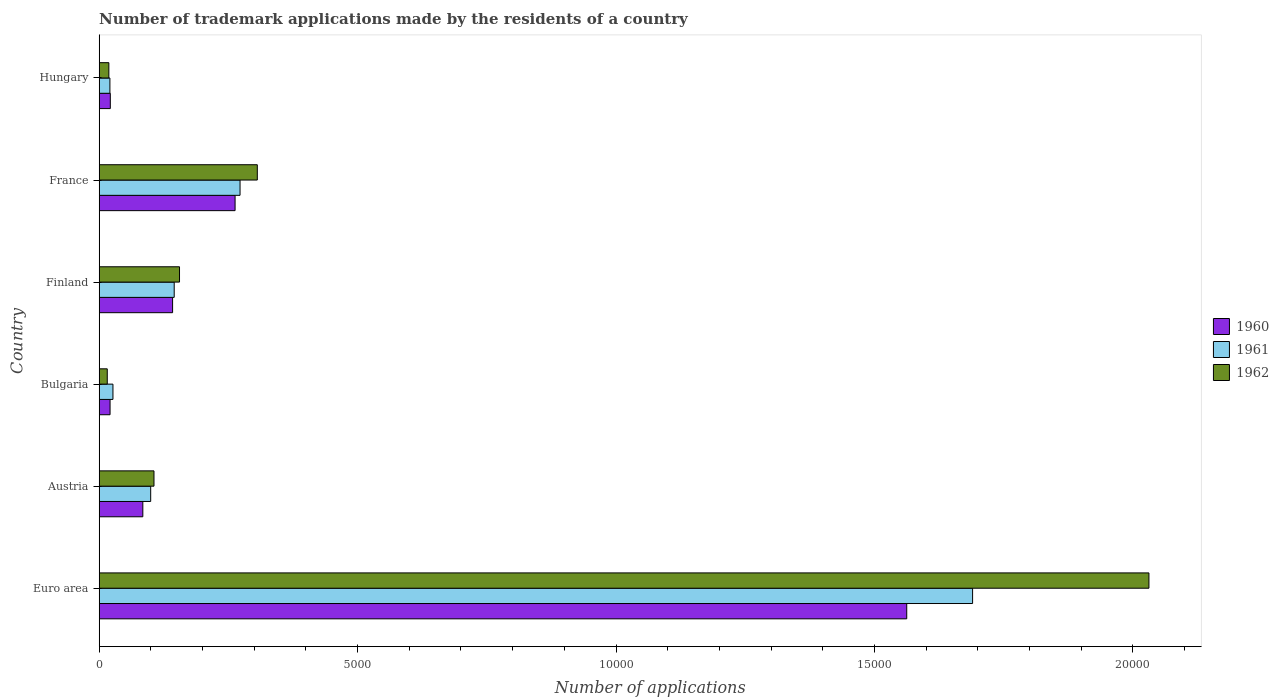What is the label of the 6th group of bars from the top?
Your answer should be compact. Euro area. What is the number of trademark applications made by the residents in 1962 in Austria?
Provide a short and direct response. 1061. Across all countries, what is the maximum number of trademark applications made by the residents in 1962?
Your response must be concise. 2.03e+04. Across all countries, what is the minimum number of trademark applications made by the residents in 1961?
Your response must be concise. 208. In which country was the number of trademark applications made by the residents in 1961 maximum?
Your answer should be very brief. Euro area. What is the total number of trademark applications made by the residents in 1961 in the graph?
Offer a very short reply. 2.25e+04. What is the difference between the number of trademark applications made by the residents in 1962 in Euro area and that in France?
Keep it short and to the point. 1.73e+04. What is the difference between the number of trademark applications made by the residents in 1960 in Bulgaria and the number of trademark applications made by the residents in 1961 in France?
Keep it short and to the point. -2515. What is the average number of trademark applications made by the residents in 1962 per country?
Offer a very short reply. 4388.67. In how many countries, is the number of trademark applications made by the residents in 1962 greater than 14000 ?
Ensure brevity in your answer.  1. What is the ratio of the number of trademark applications made by the residents in 1962 in Finland to that in Hungary?
Offer a terse response. 8.27. What is the difference between the highest and the second highest number of trademark applications made by the residents in 1962?
Your answer should be compact. 1.73e+04. What is the difference between the highest and the lowest number of trademark applications made by the residents in 1960?
Provide a short and direct response. 1.54e+04. In how many countries, is the number of trademark applications made by the residents in 1960 greater than the average number of trademark applications made by the residents in 1960 taken over all countries?
Your answer should be very brief. 1. Is the sum of the number of trademark applications made by the residents in 1961 in Euro area and Finland greater than the maximum number of trademark applications made by the residents in 1962 across all countries?
Provide a succinct answer. No. What does the 1st bar from the bottom in Hungary represents?
Your response must be concise. 1960. Is it the case that in every country, the sum of the number of trademark applications made by the residents in 1960 and number of trademark applications made by the residents in 1961 is greater than the number of trademark applications made by the residents in 1962?
Offer a terse response. Yes. Are all the bars in the graph horizontal?
Make the answer very short. Yes. Are the values on the major ticks of X-axis written in scientific E-notation?
Make the answer very short. No. Does the graph contain any zero values?
Your answer should be compact. No. Does the graph contain grids?
Offer a terse response. No. How many legend labels are there?
Your answer should be very brief. 3. What is the title of the graph?
Your response must be concise. Number of trademark applications made by the residents of a country. What is the label or title of the X-axis?
Give a very brief answer. Number of applications. What is the label or title of the Y-axis?
Give a very brief answer. Country. What is the Number of applications of 1960 in Euro area?
Provide a short and direct response. 1.56e+04. What is the Number of applications in 1961 in Euro area?
Offer a terse response. 1.69e+04. What is the Number of applications of 1962 in Euro area?
Make the answer very short. 2.03e+04. What is the Number of applications of 1960 in Austria?
Your answer should be compact. 845. What is the Number of applications in 1961 in Austria?
Offer a very short reply. 997. What is the Number of applications in 1962 in Austria?
Provide a short and direct response. 1061. What is the Number of applications in 1960 in Bulgaria?
Provide a short and direct response. 211. What is the Number of applications in 1961 in Bulgaria?
Keep it short and to the point. 267. What is the Number of applications of 1962 in Bulgaria?
Your answer should be very brief. 157. What is the Number of applications of 1960 in Finland?
Provide a succinct answer. 1421. What is the Number of applications of 1961 in Finland?
Your answer should be very brief. 1452. What is the Number of applications of 1962 in Finland?
Make the answer very short. 1555. What is the Number of applications in 1960 in France?
Keep it short and to the point. 2630. What is the Number of applications in 1961 in France?
Provide a succinct answer. 2726. What is the Number of applications of 1962 in France?
Offer a very short reply. 3060. What is the Number of applications in 1960 in Hungary?
Your answer should be very brief. 216. What is the Number of applications of 1961 in Hungary?
Offer a very short reply. 208. What is the Number of applications in 1962 in Hungary?
Provide a short and direct response. 188. Across all countries, what is the maximum Number of applications in 1960?
Your answer should be very brief. 1.56e+04. Across all countries, what is the maximum Number of applications of 1961?
Offer a terse response. 1.69e+04. Across all countries, what is the maximum Number of applications in 1962?
Offer a terse response. 2.03e+04. Across all countries, what is the minimum Number of applications in 1960?
Your answer should be compact. 211. Across all countries, what is the minimum Number of applications in 1961?
Offer a terse response. 208. Across all countries, what is the minimum Number of applications in 1962?
Provide a short and direct response. 157. What is the total Number of applications in 1960 in the graph?
Your response must be concise. 2.09e+04. What is the total Number of applications in 1961 in the graph?
Provide a succinct answer. 2.25e+04. What is the total Number of applications of 1962 in the graph?
Your answer should be very brief. 2.63e+04. What is the difference between the Number of applications in 1960 in Euro area and that in Austria?
Keep it short and to the point. 1.48e+04. What is the difference between the Number of applications in 1961 in Euro area and that in Austria?
Your answer should be very brief. 1.59e+04. What is the difference between the Number of applications of 1962 in Euro area and that in Austria?
Provide a succinct answer. 1.92e+04. What is the difference between the Number of applications of 1960 in Euro area and that in Bulgaria?
Your response must be concise. 1.54e+04. What is the difference between the Number of applications of 1961 in Euro area and that in Bulgaria?
Your response must be concise. 1.66e+04. What is the difference between the Number of applications of 1962 in Euro area and that in Bulgaria?
Offer a very short reply. 2.02e+04. What is the difference between the Number of applications of 1960 in Euro area and that in Finland?
Your answer should be very brief. 1.42e+04. What is the difference between the Number of applications of 1961 in Euro area and that in Finland?
Make the answer very short. 1.54e+04. What is the difference between the Number of applications of 1962 in Euro area and that in Finland?
Your answer should be very brief. 1.88e+04. What is the difference between the Number of applications in 1960 in Euro area and that in France?
Offer a terse response. 1.30e+04. What is the difference between the Number of applications of 1961 in Euro area and that in France?
Keep it short and to the point. 1.42e+04. What is the difference between the Number of applications in 1962 in Euro area and that in France?
Your answer should be very brief. 1.73e+04. What is the difference between the Number of applications of 1960 in Euro area and that in Hungary?
Provide a short and direct response. 1.54e+04. What is the difference between the Number of applications in 1961 in Euro area and that in Hungary?
Your response must be concise. 1.67e+04. What is the difference between the Number of applications in 1962 in Euro area and that in Hungary?
Ensure brevity in your answer.  2.01e+04. What is the difference between the Number of applications of 1960 in Austria and that in Bulgaria?
Offer a terse response. 634. What is the difference between the Number of applications in 1961 in Austria and that in Bulgaria?
Provide a succinct answer. 730. What is the difference between the Number of applications in 1962 in Austria and that in Bulgaria?
Your answer should be compact. 904. What is the difference between the Number of applications of 1960 in Austria and that in Finland?
Your answer should be compact. -576. What is the difference between the Number of applications of 1961 in Austria and that in Finland?
Provide a short and direct response. -455. What is the difference between the Number of applications of 1962 in Austria and that in Finland?
Provide a succinct answer. -494. What is the difference between the Number of applications of 1960 in Austria and that in France?
Give a very brief answer. -1785. What is the difference between the Number of applications of 1961 in Austria and that in France?
Your answer should be very brief. -1729. What is the difference between the Number of applications of 1962 in Austria and that in France?
Offer a very short reply. -1999. What is the difference between the Number of applications in 1960 in Austria and that in Hungary?
Your answer should be very brief. 629. What is the difference between the Number of applications of 1961 in Austria and that in Hungary?
Give a very brief answer. 789. What is the difference between the Number of applications in 1962 in Austria and that in Hungary?
Make the answer very short. 873. What is the difference between the Number of applications of 1960 in Bulgaria and that in Finland?
Your response must be concise. -1210. What is the difference between the Number of applications in 1961 in Bulgaria and that in Finland?
Your response must be concise. -1185. What is the difference between the Number of applications in 1962 in Bulgaria and that in Finland?
Provide a succinct answer. -1398. What is the difference between the Number of applications of 1960 in Bulgaria and that in France?
Your answer should be very brief. -2419. What is the difference between the Number of applications of 1961 in Bulgaria and that in France?
Your answer should be compact. -2459. What is the difference between the Number of applications of 1962 in Bulgaria and that in France?
Make the answer very short. -2903. What is the difference between the Number of applications in 1960 in Bulgaria and that in Hungary?
Your response must be concise. -5. What is the difference between the Number of applications in 1962 in Bulgaria and that in Hungary?
Keep it short and to the point. -31. What is the difference between the Number of applications of 1960 in Finland and that in France?
Your answer should be compact. -1209. What is the difference between the Number of applications in 1961 in Finland and that in France?
Provide a short and direct response. -1274. What is the difference between the Number of applications in 1962 in Finland and that in France?
Provide a short and direct response. -1505. What is the difference between the Number of applications in 1960 in Finland and that in Hungary?
Give a very brief answer. 1205. What is the difference between the Number of applications of 1961 in Finland and that in Hungary?
Provide a succinct answer. 1244. What is the difference between the Number of applications in 1962 in Finland and that in Hungary?
Give a very brief answer. 1367. What is the difference between the Number of applications in 1960 in France and that in Hungary?
Provide a short and direct response. 2414. What is the difference between the Number of applications in 1961 in France and that in Hungary?
Offer a very short reply. 2518. What is the difference between the Number of applications of 1962 in France and that in Hungary?
Your response must be concise. 2872. What is the difference between the Number of applications of 1960 in Euro area and the Number of applications of 1961 in Austria?
Keep it short and to the point. 1.46e+04. What is the difference between the Number of applications of 1960 in Euro area and the Number of applications of 1962 in Austria?
Keep it short and to the point. 1.46e+04. What is the difference between the Number of applications in 1961 in Euro area and the Number of applications in 1962 in Austria?
Keep it short and to the point. 1.58e+04. What is the difference between the Number of applications in 1960 in Euro area and the Number of applications in 1961 in Bulgaria?
Keep it short and to the point. 1.54e+04. What is the difference between the Number of applications of 1960 in Euro area and the Number of applications of 1962 in Bulgaria?
Your answer should be very brief. 1.55e+04. What is the difference between the Number of applications in 1961 in Euro area and the Number of applications in 1962 in Bulgaria?
Offer a very short reply. 1.67e+04. What is the difference between the Number of applications of 1960 in Euro area and the Number of applications of 1961 in Finland?
Offer a very short reply. 1.42e+04. What is the difference between the Number of applications of 1960 in Euro area and the Number of applications of 1962 in Finland?
Offer a very short reply. 1.41e+04. What is the difference between the Number of applications of 1961 in Euro area and the Number of applications of 1962 in Finland?
Your answer should be compact. 1.53e+04. What is the difference between the Number of applications in 1960 in Euro area and the Number of applications in 1961 in France?
Provide a succinct answer. 1.29e+04. What is the difference between the Number of applications of 1960 in Euro area and the Number of applications of 1962 in France?
Your answer should be compact. 1.26e+04. What is the difference between the Number of applications in 1961 in Euro area and the Number of applications in 1962 in France?
Provide a succinct answer. 1.38e+04. What is the difference between the Number of applications in 1960 in Euro area and the Number of applications in 1961 in Hungary?
Your response must be concise. 1.54e+04. What is the difference between the Number of applications of 1960 in Euro area and the Number of applications of 1962 in Hungary?
Your answer should be very brief. 1.54e+04. What is the difference between the Number of applications of 1961 in Euro area and the Number of applications of 1962 in Hungary?
Give a very brief answer. 1.67e+04. What is the difference between the Number of applications of 1960 in Austria and the Number of applications of 1961 in Bulgaria?
Keep it short and to the point. 578. What is the difference between the Number of applications in 1960 in Austria and the Number of applications in 1962 in Bulgaria?
Keep it short and to the point. 688. What is the difference between the Number of applications in 1961 in Austria and the Number of applications in 1962 in Bulgaria?
Provide a succinct answer. 840. What is the difference between the Number of applications in 1960 in Austria and the Number of applications in 1961 in Finland?
Your response must be concise. -607. What is the difference between the Number of applications in 1960 in Austria and the Number of applications in 1962 in Finland?
Offer a very short reply. -710. What is the difference between the Number of applications in 1961 in Austria and the Number of applications in 1962 in Finland?
Make the answer very short. -558. What is the difference between the Number of applications of 1960 in Austria and the Number of applications of 1961 in France?
Your response must be concise. -1881. What is the difference between the Number of applications in 1960 in Austria and the Number of applications in 1962 in France?
Offer a very short reply. -2215. What is the difference between the Number of applications in 1961 in Austria and the Number of applications in 1962 in France?
Provide a short and direct response. -2063. What is the difference between the Number of applications in 1960 in Austria and the Number of applications in 1961 in Hungary?
Offer a terse response. 637. What is the difference between the Number of applications of 1960 in Austria and the Number of applications of 1962 in Hungary?
Provide a succinct answer. 657. What is the difference between the Number of applications of 1961 in Austria and the Number of applications of 1962 in Hungary?
Ensure brevity in your answer.  809. What is the difference between the Number of applications of 1960 in Bulgaria and the Number of applications of 1961 in Finland?
Give a very brief answer. -1241. What is the difference between the Number of applications in 1960 in Bulgaria and the Number of applications in 1962 in Finland?
Offer a terse response. -1344. What is the difference between the Number of applications of 1961 in Bulgaria and the Number of applications of 1962 in Finland?
Your answer should be compact. -1288. What is the difference between the Number of applications of 1960 in Bulgaria and the Number of applications of 1961 in France?
Keep it short and to the point. -2515. What is the difference between the Number of applications in 1960 in Bulgaria and the Number of applications in 1962 in France?
Your response must be concise. -2849. What is the difference between the Number of applications in 1961 in Bulgaria and the Number of applications in 1962 in France?
Provide a short and direct response. -2793. What is the difference between the Number of applications of 1960 in Bulgaria and the Number of applications of 1961 in Hungary?
Your answer should be compact. 3. What is the difference between the Number of applications in 1960 in Bulgaria and the Number of applications in 1962 in Hungary?
Give a very brief answer. 23. What is the difference between the Number of applications of 1961 in Bulgaria and the Number of applications of 1962 in Hungary?
Your answer should be very brief. 79. What is the difference between the Number of applications in 1960 in Finland and the Number of applications in 1961 in France?
Offer a terse response. -1305. What is the difference between the Number of applications in 1960 in Finland and the Number of applications in 1962 in France?
Ensure brevity in your answer.  -1639. What is the difference between the Number of applications in 1961 in Finland and the Number of applications in 1962 in France?
Provide a succinct answer. -1608. What is the difference between the Number of applications of 1960 in Finland and the Number of applications of 1961 in Hungary?
Provide a succinct answer. 1213. What is the difference between the Number of applications of 1960 in Finland and the Number of applications of 1962 in Hungary?
Offer a terse response. 1233. What is the difference between the Number of applications of 1961 in Finland and the Number of applications of 1962 in Hungary?
Ensure brevity in your answer.  1264. What is the difference between the Number of applications in 1960 in France and the Number of applications in 1961 in Hungary?
Give a very brief answer. 2422. What is the difference between the Number of applications in 1960 in France and the Number of applications in 1962 in Hungary?
Give a very brief answer. 2442. What is the difference between the Number of applications of 1961 in France and the Number of applications of 1962 in Hungary?
Your response must be concise. 2538. What is the average Number of applications of 1960 per country?
Offer a very short reply. 3491.33. What is the average Number of applications of 1961 per country?
Offer a very short reply. 3758.17. What is the average Number of applications of 1962 per country?
Keep it short and to the point. 4388.67. What is the difference between the Number of applications in 1960 and Number of applications in 1961 in Euro area?
Your answer should be very brief. -1274. What is the difference between the Number of applications of 1960 and Number of applications of 1962 in Euro area?
Your answer should be compact. -4686. What is the difference between the Number of applications of 1961 and Number of applications of 1962 in Euro area?
Give a very brief answer. -3412. What is the difference between the Number of applications in 1960 and Number of applications in 1961 in Austria?
Your answer should be very brief. -152. What is the difference between the Number of applications in 1960 and Number of applications in 1962 in Austria?
Ensure brevity in your answer.  -216. What is the difference between the Number of applications of 1961 and Number of applications of 1962 in Austria?
Make the answer very short. -64. What is the difference between the Number of applications in 1960 and Number of applications in 1961 in Bulgaria?
Your response must be concise. -56. What is the difference between the Number of applications in 1961 and Number of applications in 1962 in Bulgaria?
Offer a very short reply. 110. What is the difference between the Number of applications of 1960 and Number of applications of 1961 in Finland?
Give a very brief answer. -31. What is the difference between the Number of applications in 1960 and Number of applications in 1962 in Finland?
Keep it short and to the point. -134. What is the difference between the Number of applications in 1961 and Number of applications in 1962 in Finland?
Make the answer very short. -103. What is the difference between the Number of applications of 1960 and Number of applications of 1961 in France?
Give a very brief answer. -96. What is the difference between the Number of applications in 1960 and Number of applications in 1962 in France?
Give a very brief answer. -430. What is the difference between the Number of applications in 1961 and Number of applications in 1962 in France?
Offer a very short reply. -334. What is the difference between the Number of applications in 1960 and Number of applications in 1961 in Hungary?
Make the answer very short. 8. What is the ratio of the Number of applications of 1960 in Euro area to that in Austria?
Offer a terse response. 18.49. What is the ratio of the Number of applications of 1961 in Euro area to that in Austria?
Ensure brevity in your answer.  16.95. What is the ratio of the Number of applications in 1962 in Euro area to that in Austria?
Provide a succinct answer. 19.14. What is the ratio of the Number of applications in 1960 in Euro area to that in Bulgaria?
Your answer should be very brief. 74.05. What is the ratio of the Number of applications of 1961 in Euro area to that in Bulgaria?
Offer a very short reply. 63.29. What is the ratio of the Number of applications in 1962 in Euro area to that in Bulgaria?
Ensure brevity in your answer.  129.37. What is the ratio of the Number of applications of 1960 in Euro area to that in Finland?
Provide a short and direct response. 11. What is the ratio of the Number of applications of 1961 in Euro area to that in Finland?
Make the answer very short. 11.64. What is the ratio of the Number of applications of 1962 in Euro area to that in Finland?
Provide a succinct answer. 13.06. What is the ratio of the Number of applications in 1960 in Euro area to that in France?
Provide a short and direct response. 5.94. What is the ratio of the Number of applications of 1961 in Euro area to that in France?
Your answer should be compact. 6.2. What is the ratio of the Number of applications of 1962 in Euro area to that in France?
Offer a terse response. 6.64. What is the ratio of the Number of applications of 1960 in Euro area to that in Hungary?
Provide a short and direct response. 72.34. What is the ratio of the Number of applications of 1961 in Euro area to that in Hungary?
Give a very brief answer. 81.25. What is the ratio of the Number of applications in 1962 in Euro area to that in Hungary?
Ensure brevity in your answer.  108.04. What is the ratio of the Number of applications in 1960 in Austria to that in Bulgaria?
Keep it short and to the point. 4. What is the ratio of the Number of applications of 1961 in Austria to that in Bulgaria?
Keep it short and to the point. 3.73. What is the ratio of the Number of applications of 1962 in Austria to that in Bulgaria?
Ensure brevity in your answer.  6.76. What is the ratio of the Number of applications in 1960 in Austria to that in Finland?
Offer a terse response. 0.59. What is the ratio of the Number of applications in 1961 in Austria to that in Finland?
Your answer should be very brief. 0.69. What is the ratio of the Number of applications of 1962 in Austria to that in Finland?
Your answer should be very brief. 0.68. What is the ratio of the Number of applications in 1960 in Austria to that in France?
Offer a very short reply. 0.32. What is the ratio of the Number of applications of 1961 in Austria to that in France?
Make the answer very short. 0.37. What is the ratio of the Number of applications of 1962 in Austria to that in France?
Make the answer very short. 0.35. What is the ratio of the Number of applications in 1960 in Austria to that in Hungary?
Keep it short and to the point. 3.91. What is the ratio of the Number of applications in 1961 in Austria to that in Hungary?
Offer a terse response. 4.79. What is the ratio of the Number of applications in 1962 in Austria to that in Hungary?
Offer a very short reply. 5.64. What is the ratio of the Number of applications of 1960 in Bulgaria to that in Finland?
Your answer should be compact. 0.15. What is the ratio of the Number of applications in 1961 in Bulgaria to that in Finland?
Offer a very short reply. 0.18. What is the ratio of the Number of applications in 1962 in Bulgaria to that in Finland?
Offer a terse response. 0.1. What is the ratio of the Number of applications in 1960 in Bulgaria to that in France?
Offer a very short reply. 0.08. What is the ratio of the Number of applications of 1961 in Bulgaria to that in France?
Make the answer very short. 0.1. What is the ratio of the Number of applications in 1962 in Bulgaria to that in France?
Offer a very short reply. 0.05. What is the ratio of the Number of applications in 1960 in Bulgaria to that in Hungary?
Your response must be concise. 0.98. What is the ratio of the Number of applications of 1961 in Bulgaria to that in Hungary?
Offer a terse response. 1.28. What is the ratio of the Number of applications in 1962 in Bulgaria to that in Hungary?
Provide a short and direct response. 0.84. What is the ratio of the Number of applications in 1960 in Finland to that in France?
Provide a succinct answer. 0.54. What is the ratio of the Number of applications in 1961 in Finland to that in France?
Keep it short and to the point. 0.53. What is the ratio of the Number of applications of 1962 in Finland to that in France?
Your answer should be compact. 0.51. What is the ratio of the Number of applications of 1960 in Finland to that in Hungary?
Your answer should be very brief. 6.58. What is the ratio of the Number of applications of 1961 in Finland to that in Hungary?
Your answer should be very brief. 6.98. What is the ratio of the Number of applications of 1962 in Finland to that in Hungary?
Your response must be concise. 8.27. What is the ratio of the Number of applications of 1960 in France to that in Hungary?
Offer a terse response. 12.18. What is the ratio of the Number of applications in 1961 in France to that in Hungary?
Ensure brevity in your answer.  13.11. What is the ratio of the Number of applications in 1962 in France to that in Hungary?
Make the answer very short. 16.28. What is the difference between the highest and the second highest Number of applications of 1960?
Make the answer very short. 1.30e+04. What is the difference between the highest and the second highest Number of applications of 1961?
Provide a short and direct response. 1.42e+04. What is the difference between the highest and the second highest Number of applications of 1962?
Keep it short and to the point. 1.73e+04. What is the difference between the highest and the lowest Number of applications of 1960?
Your answer should be compact. 1.54e+04. What is the difference between the highest and the lowest Number of applications of 1961?
Make the answer very short. 1.67e+04. What is the difference between the highest and the lowest Number of applications in 1962?
Offer a very short reply. 2.02e+04. 